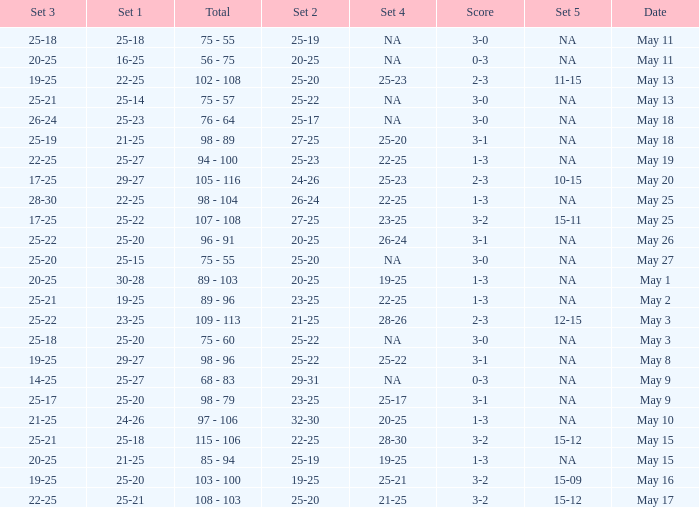What is the set 2 the has 1 set of 21-25, and 4 sets of 25-20? 27-25. 